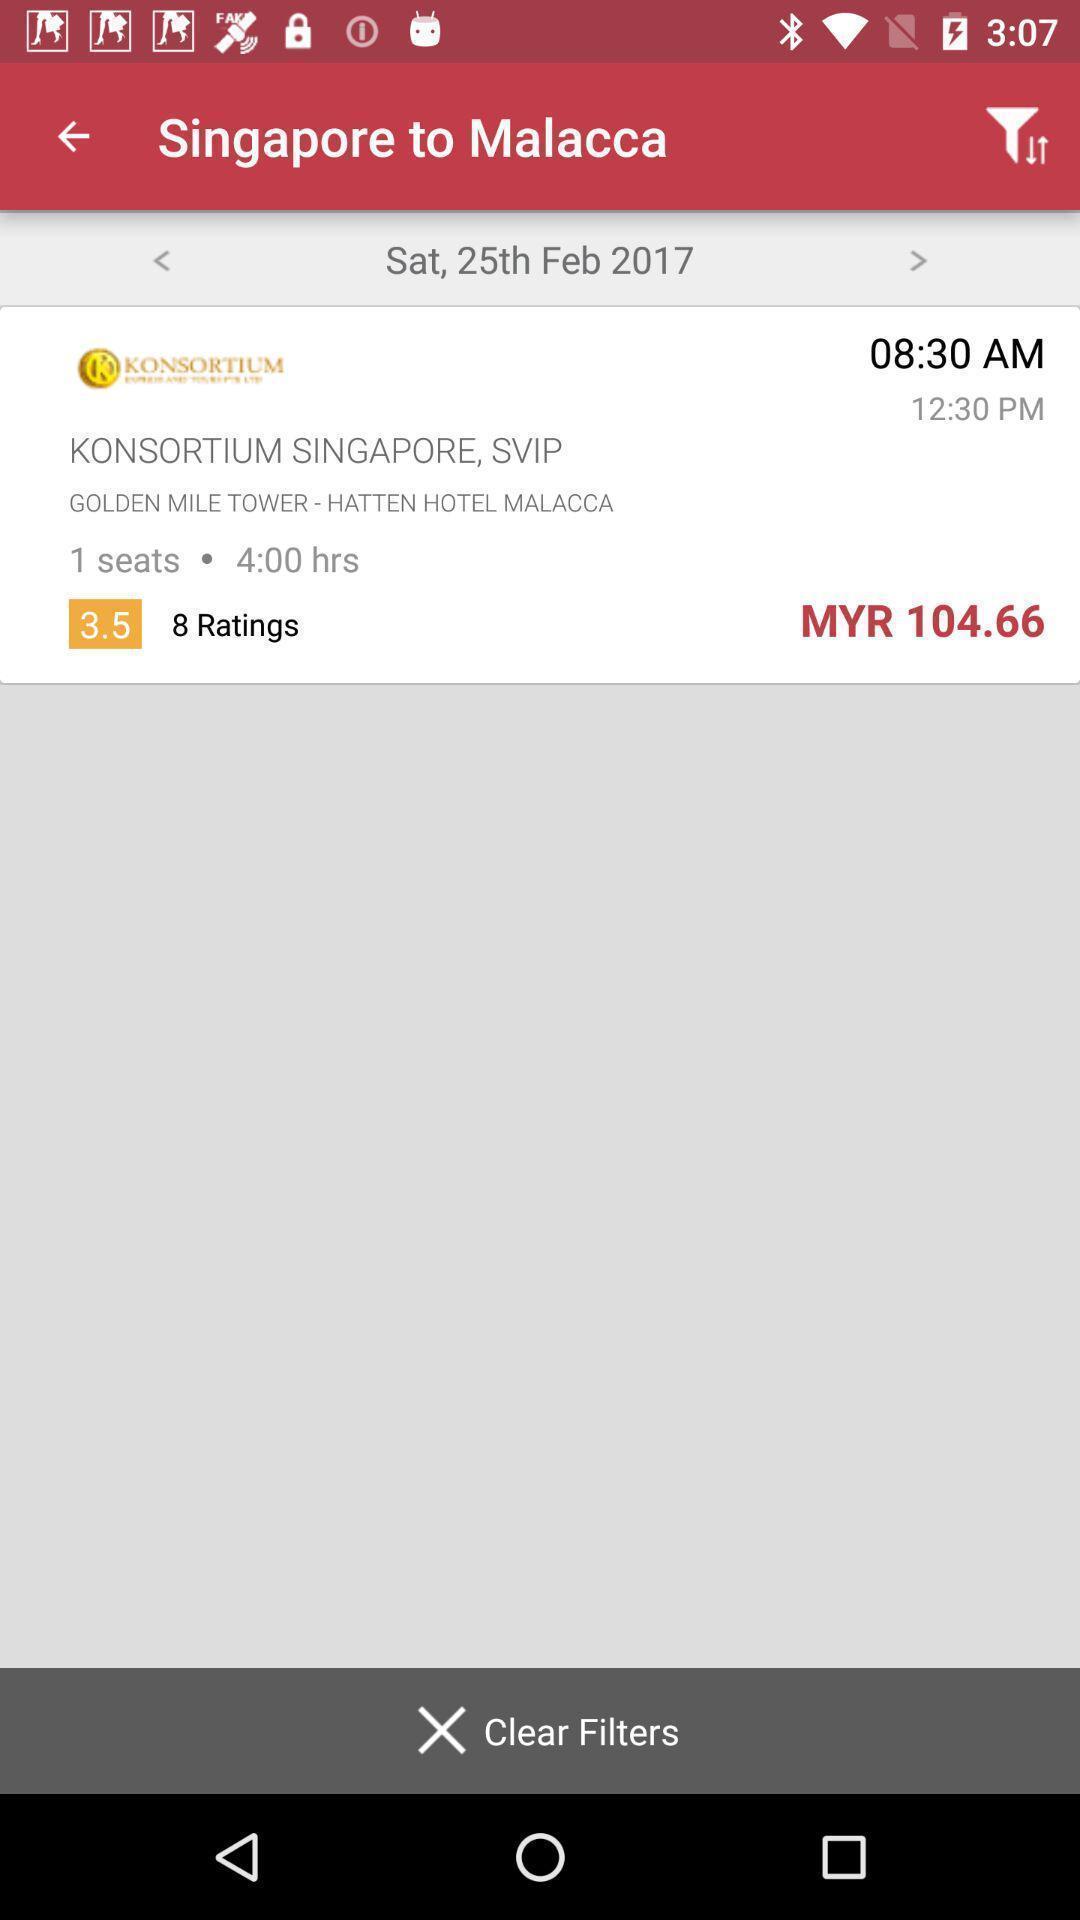Provide a detailed account of this screenshot. Screen shows trip details page in bus booking application. 